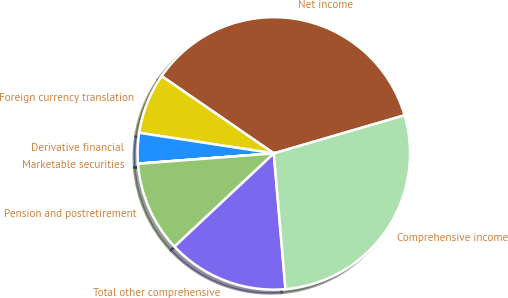Convert chart to OTSL. <chart><loc_0><loc_0><loc_500><loc_500><pie_chart><fcel>Net income<fcel>Foreign currency translation<fcel>Derivative financial<fcel>Marketable securities<fcel>Pension and postretirement<fcel>Total other comprehensive<fcel>Comprehensive income<nl><fcel>35.89%<fcel>7.19%<fcel>3.61%<fcel>0.02%<fcel>10.78%<fcel>14.37%<fcel>28.15%<nl></chart> 